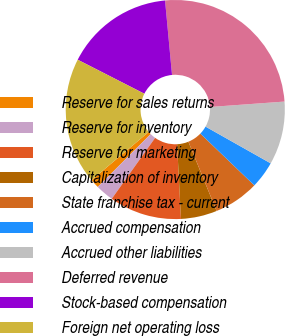Convert chart. <chart><loc_0><loc_0><loc_500><loc_500><pie_chart><fcel>Reserve for sales returns<fcel>Reserve for inventory<fcel>Reserve for marketing<fcel>Capitalization of inventory<fcel>State franchise tax - current<fcel>Accrued compensation<fcel>Accrued other liabilities<fcel>Deferred revenue<fcel>Stock-based compensation<fcel>Foreign net operating loss<nl><fcel>1.34%<fcel>2.67%<fcel>10.67%<fcel>5.33%<fcel>6.67%<fcel>4.0%<fcel>9.33%<fcel>25.33%<fcel>16.0%<fcel>18.66%<nl></chart> 